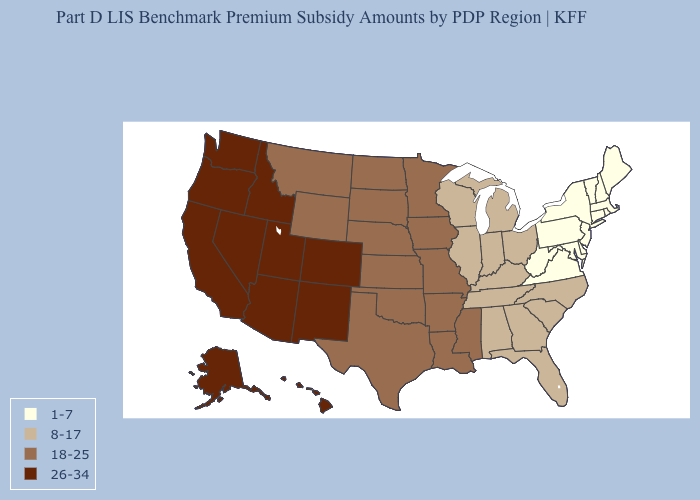Does Washington have the highest value in the USA?
Answer briefly. Yes. Name the states that have a value in the range 1-7?
Short answer required. Connecticut, Delaware, Maine, Maryland, Massachusetts, New Hampshire, New Jersey, New York, Pennsylvania, Rhode Island, Vermont, Virginia, West Virginia. Does the map have missing data?
Quick response, please. No. Is the legend a continuous bar?
Short answer required. No. Which states have the lowest value in the West?
Short answer required. Montana, Wyoming. Which states have the lowest value in the MidWest?
Short answer required. Illinois, Indiana, Michigan, Ohio, Wisconsin. Does Nebraska have the highest value in the MidWest?
Short answer required. Yes. What is the lowest value in the West?
Answer briefly. 18-25. Does the map have missing data?
Answer briefly. No. What is the value of Florida?
Concise answer only. 8-17. What is the value of New Jersey?
Write a very short answer. 1-7. Does Georgia have a lower value than Kansas?
Quick response, please. Yes. Name the states that have a value in the range 26-34?
Be succinct. Alaska, Arizona, California, Colorado, Hawaii, Idaho, Nevada, New Mexico, Oregon, Utah, Washington. What is the lowest value in the USA?
Quick response, please. 1-7. Among the states that border Virginia , does Kentucky have the lowest value?
Be succinct. No. 